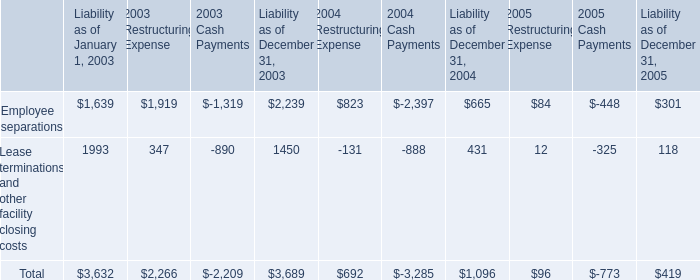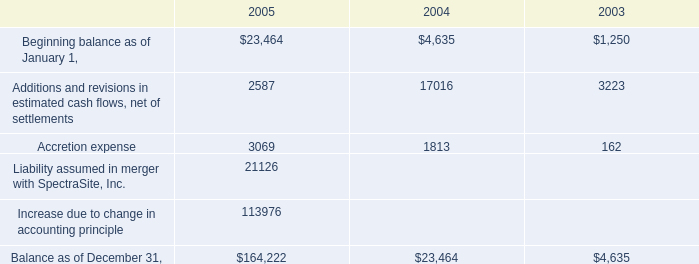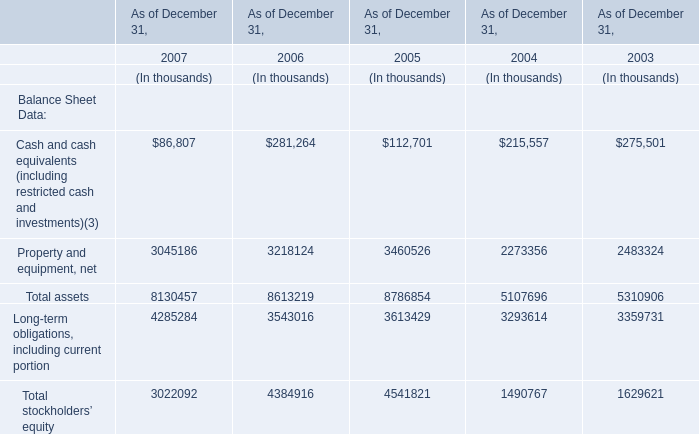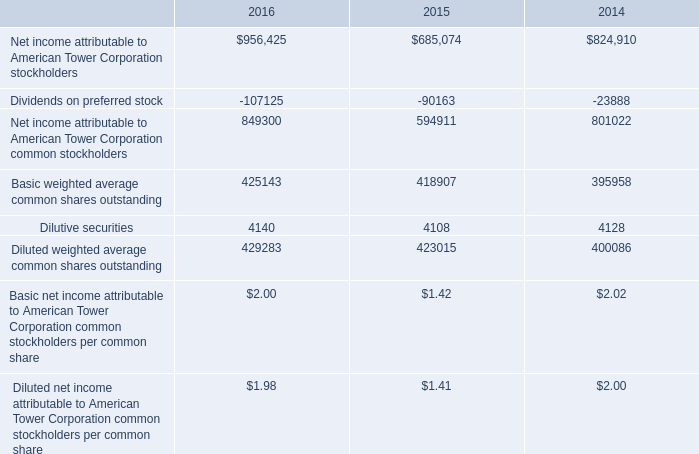What's the average of Liability assumed in merger with SpectraSite, Inc. of 2005, and Net income attributable to American Tower Corporation stockholders of 2016 ? 
Computations: ((21126.0 + 956425.0) / 2)
Answer: 488775.5. 